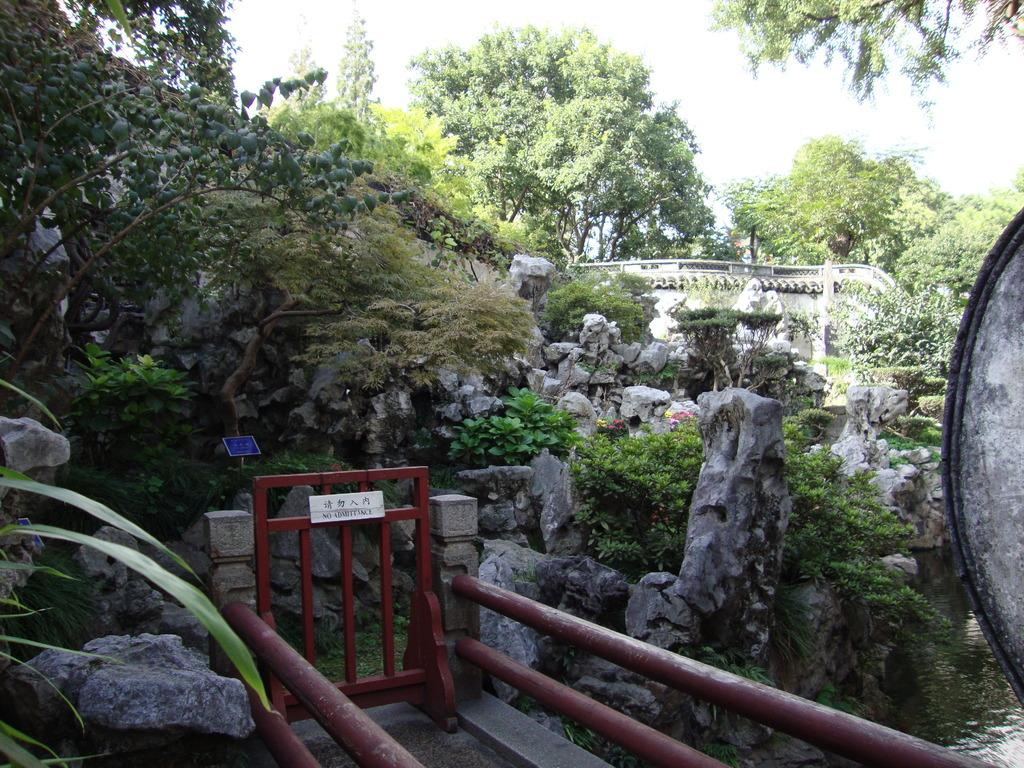What type of structure can be seen in the image? There is a handrail and a gate in the image. What natural elements are present in the image? There are plants, rocks, and trees in the image. What is on the right side of the image? There is a wall on the right side of the image. What is the condition of the sky in the image? The sky is clear in the image. How many babies are crawling on the handrail in the image? There are no babies present in the image, and therefore no such activity can be observed. What color is the sock hanging on the gate in the image? There is no sock present in the image. 